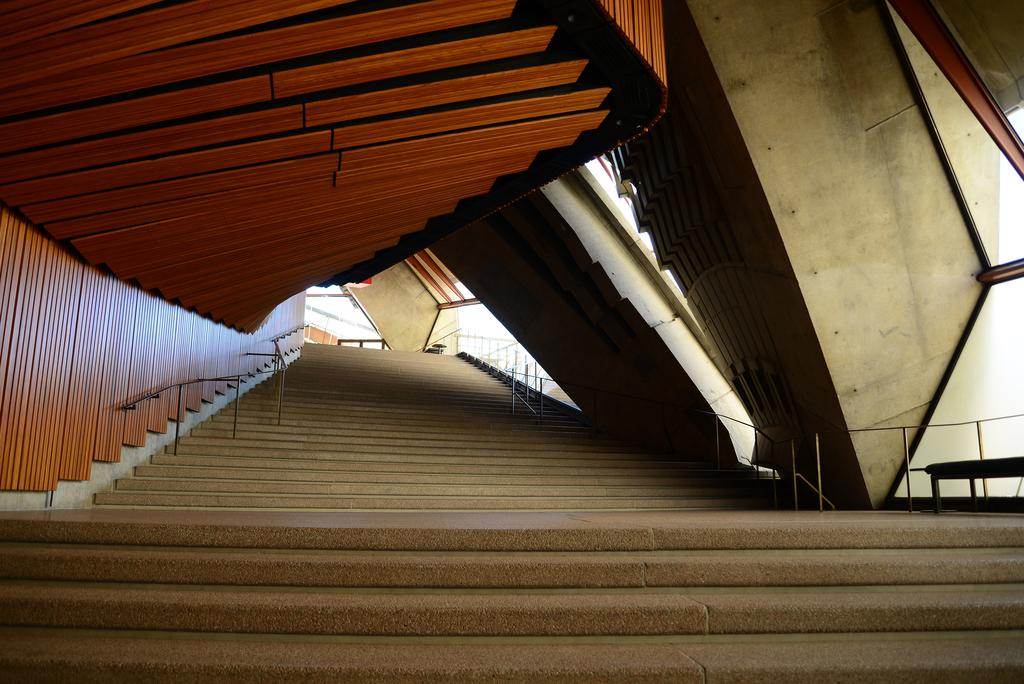What is the main feature in the center of the image? There is a staircase in the center of the image. What safety feature is present on the staircase? The staircase has railings. What can be seen in the background of the image? There are walls visible in the background of the image. What type of advertisement can be seen on the car in the image? There is no car present in the image, so there cannot be an advertisement on a car. 